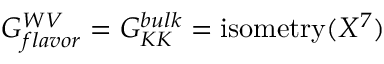Convert formula to latex. <formula><loc_0><loc_0><loc_500><loc_500>G _ { f l a v o r } ^ { W V } = G _ { K K } ^ { b u l k } = i s o m e t r y ( X ^ { 7 } )</formula> 